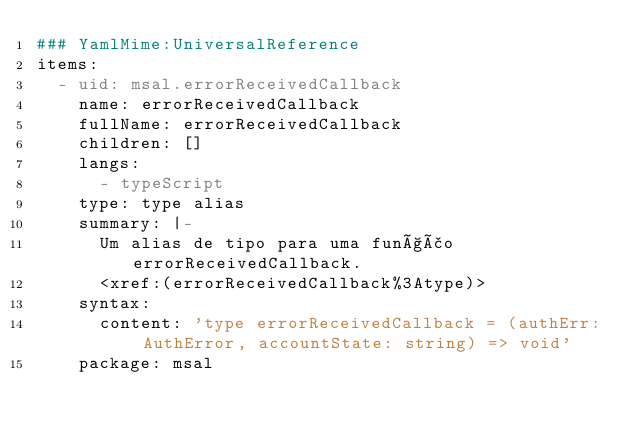<code> <loc_0><loc_0><loc_500><loc_500><_YAML_>### YamlMime:UniversalReference
items:
  - uid: msal.errorReceivedCallback
    name: errorReceivedCallback
    fullName: errorReceivedCallback
    children: []
    langs:
      - typeScript
    type: type alias
    summary: |-
      Um alias de tipo para uma função errorReceivedCallback.
      <xref:(errorReceivedCallback%3Atype)>
    syntax:
      content: 'type errorReceivedCallback = (authErr: AuthError, accountState: string) => void'
    package: msal</code> 